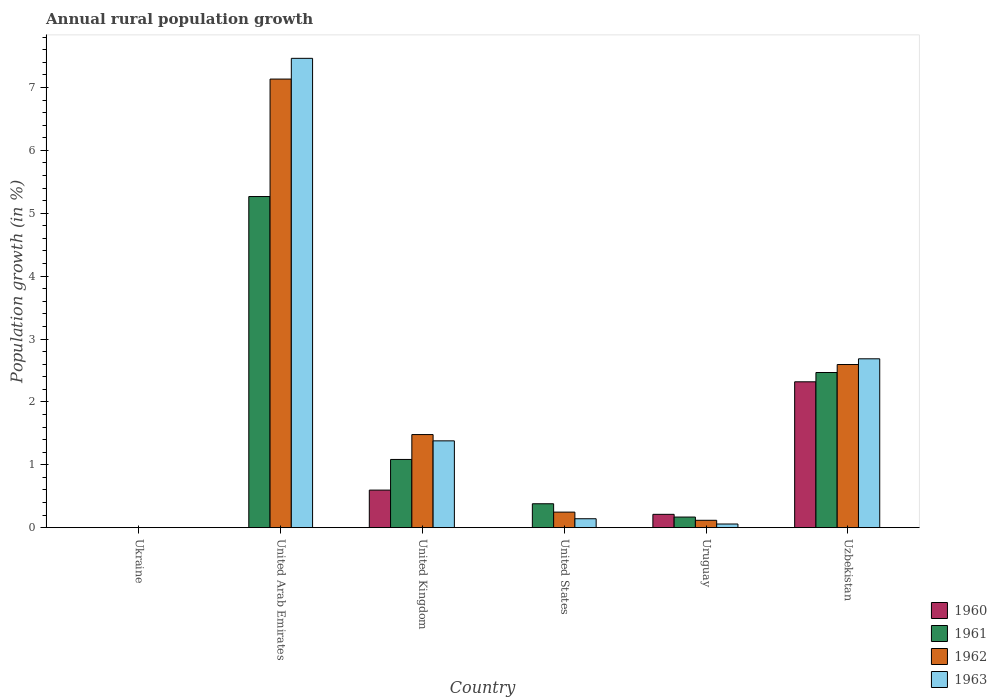How many different coloured bars are there?
Your answer should be very brief. 4. Are the number of bars per tick equal to the number of legend labels?
Provide a succinct answer. No. How many bars are there on the 6th tick from the right?
Provide a short and direct response. 0. What is the label of the 2nd group of bars from the left?
Provide a short and direct response. United Arab Emirates. In how many cases, is the number of bars for a given country not equal to the number of legend labels?
Provide a succinct answer. 3. Across all countries, what is the maximum percentage of rural population growth in 1961?
Make the answer very short. 5.27. In which country was the percentage of rural population growth in 1960 maximum?
Ensure brevity in your answer.  Uzbekistan. What is the total percentage of rural population growth in 1961 in the graph?
Provide a succinct answer. 9.37. What is the difference between the percentage of rural population growth in 1962 in United States and that in Uzbekistan?
Provide a succinct answer. -2.35. What is the difference between the percentage of rural population growth in 1962 in United Kingdom and the percentage of rural population growth in 1961 in United Arab Emirates?
Keep it short and to the point. -3.79. What is the average percentage of rural population growth in 1961 per country?
Provide a succinct answer. 1.56. What is the difference between the percentage of rural population growth of/in 1961 and percentage of rural population growth of/in 1963 in United Arab Emirates?
Make the answer very short. -2.2. What is the ratio of the percentage of rural population growth in 1962 in United Kingdom to that in Uzbekistan?
Provide a succinct answer. 0.57. What is the difference between the highest and the second highest percentage of rural population growth in 1961?
Ensure brevity in your answer.  -1.38. What is the difference between the highest and the lowest percentage of rural population growth in 1960?
Offer a very short reply. 2.32. Is it the case that in every country, the sum of the percentage of rural population growth in 1960 and percentage of rural population growth in 1963 is greater than the sum of percentage of rural population growth in 1961 and percentage of rural population growth in 1962?
Provide a short and direct response. No. How many bars are there?
Offer a terse response. 18. Are all the bars in the graph horizontal?
Provide a succinct answer. No. Does the graph contain any zero values?
Ensure brevity in your answer.  Yes. Does the graph contain grids?
Give a very brief answer. No. Where does the legend appear in the graph?
Provide a succinct answer. Bottom right. How many legend labels are there?
Make the answer very short. 4. How are the legend labels stacked?
Offer a terse response. Vertical. What is the title of the graph?
Ensure brevity in your answer.  Annual rural population growth. Does "1985" appear as one of the legend labels in the graph?
Keep it short and to the point. No. What is the label or title of the Y-axis?
Your answer should be very brief. Population growth (in %). What is the Population growth (in %) of 1960 in Ukraine?
Make the answer very short. 0. What is the Population growth (in %) of 1962 in Ukraine?
Your response must be concise. 0. What is the Population growth (in %) in 1963 in Ukraine?
Your answer should be very brief. 0. What is the Population growth (in %) of 1961 in United Arab Emirates?
Make the answer very short. 5.27. What is the Population growth (in %) of 1962 in United Arab Emirates?
Your answer should be very brief. 7.13. What is the Population growth (in %) in 1963 in United Arab Emirates?
Offer a terse response. 7.46. What is the Population growth (in %) of 1960 in United Kingdom?
Offer a terse response. 0.6. What is the Population growth (in %) in 1961 in United Kingdom?
Ensure brevity in your answer.  1.08. What is the Population growth (in %) of 1962 in United Kingdom?
Give a very brief answer. 1.48. What is the Population growth (in %) in 1963 in United Kingdom?
Your answer should be compact. 1.38. What is the Population growth (in %) in 1960 in United States?
Your answer should be very brief. 0. What is the Population growth (in %) in 1961 in United States?
Give a very brief answer. 0.38. What is the Population growth (in %) in 1962 in United States?
Offer a terse response. 0.25. What is the Population growth (in %) of 1963 in United States?
Offer a very short reply. 0.14. What is the Population growth (in %) of 1960 in Uruguay?
Give a very brief answer. 0.21. What is the Population growth (in %) of 1961 in Uruguay?
Offer a terse response. 0.17. What is the Population growth (in %) of 1962 in Uruguay?
Offer a very short reply. 0.12. What is the Population growth (in %) of 1963 in Uruguay?
Provide a succinct answer. 0.06. What is the Population growth (in %) in 1960 in Uzbekistan?
Your response must be concise. 2.32. What is the Population growth (in %) of 1961 in Uzbekistan?
Give a very brief answer. 2.47. What is the Population growth (in %) of 1962 in Uzbekistan?
Your answer should be compact. 2.59. What is the Population growth (in %) in 1963 in Uzbekistan?
Provide a succinct answer. 2.69. Across all countries, what is the maximum Population growth (in %) of 1960?
Offer a very short reply. 2.32. Across all countries, what is the maximum Population growth (in %) in 1961?
Offer a terse response. 5.27. Across all countries, what is the maximum Population growth (in %) of 1962?
Provide a short and direct response. 7.13. Across all countries, what is the maximum Population growth (in %) in 1963?
Keep it short and to the point. 7.46. Across all countries, what is the minimum Population growth (in %) of 1963?
Provide a short and direct response. 0. What is the total Population growth (in %) of 1960 in the graph?
Give a very brief answer. 3.13. What is the total Population growth (in %) of 1961 in the graph?
Provide a short and direct response. 9.37. What is the total Population growth (in %) of 1962 in the graph?
Provide a short and direct response. 11.57. What is the total Population growth (in %) of 1963 in the graph?
Keep it short and to the point. 11.73. What is the difference between the Population growth (in %) in 1961 in United Arab Emirates and that in United Kingdom?
Offer a very short reply. 4.18. What is the difference between the Population growth (in %) of 1962 in United Arab Emirates and that in United Kingdom?
Provide a succinct answer. 5.65. What is the difference between the Population growth (in %) in 1963 in United Arab Emirates and that in United Kingdom?
Offer a very short reply. 6.08. What is the difference between the Population growth (in %) in 1961 in United Arab Emirates and that in United States?
Provide a short and direct response. 4.89. What is the difference between the Population growth (in %) of 1962 in United Arab Emirates and that in United States?
Offer a very short reply. 6.89. What is the difference between the Population growth (in %) in 1963 in United Arab Emirates and that in United States?
Keep it short and to the point. 7.32. What is the difference between the Population growth (in %) in 1961 in United Arab Emirates and that in Uruguay?
Keep it short and to the point. 5.1. What is the difference between the Population growth (in %) of 1962 in United Arab Emirates and that in Uruguay?
Give a very brief answer. 7.02. What is the difference between the Population growth (in %) of 1963 in United Arab Emirates and that in Uruguay?
Your answer should be very brief. 7.41. What is the difference between the Population growth (in %) in 1961 in United Arab Emirates and that in Uzbekistan?
Your answer should be very brief. 2.8. What is the difference between the Population growth (in %) of 1962 in United Arab Emirates and that in Uzbekistan?
Your answer should be very brief. 4.54. What is the difference between the Population growth (in %) of 1963 in United Arab Emirates and that in Uzbekistan?
Your answer should be compact. 4.78. What is the difference between the Population growth (in %) of 1961 in United Kingdom and that in United States?
Your answer should be very brief. 0.7. What is the difference between the Population growth (in %) of 1962 in United Kingdom and that in United States?
Keep it short and to the point. 1.23. What is the difference between the Population growth (in %) in 1963 in United Kingdom and that in United States?
Offer a terse response. 1.24. What is the difference between the Population growth (in %) in 1960 in United Kingdom and that in Uruguay?
Make the answer very short. 0.39. What is the difference between the Population growth (in %) in 1961 in United Kingdom and that in Uruguay?
Provide a short and direct response. 0.92. What is the difference between the Population growth (in %) of 1962 in United Kingdom and that in Uruguay?
Offer a terse response. 1.36. What is the difference between the Population growth (in %) of 1963 in United Kingdom and that in Uruguay?
Offer a very short reply. 1.32. What is the difference between the Population growth (in %) of 1960 in United Kingdom and that in Uzbekistan?
Make the answer very short. -1.72. What is the difference between the Population growth (in %) of 1961 in United Kingdom and that in Uzbekistan?
Offer a very short reply. -1.38. What is the difference between the Population growth (in %) of 1962 in United Kingdom and that in Uzbekistan?
Your answer should be compact. -1.11. What is the difference between the Population growth (in %) in 1963 in United Kingdom and that in Uzbekistan?
Keep it short and to the point. -1.3. What is the difference between the Population growth (in %) of 1961 in United States and that in Uruguay?
Provide a short and direct response. 0.21. What is the difference between the Population growth (in %) in 1962 in United States and that in Uruguay?
Ensure brevity in your answer.  0.13. What is the difference between the Population growth (in %) in 1963 in United States and that in Uruguay?
Your answer should be compact. 0.08. What is the difference between the Population growth (in %) of 1961 in United States and that in Uzbekistan?
Make the answer very short. -2.09. What is the difference between the Population growth (in %) in 1962 in United States and that in Uzbekistan?
Ensure brevity in your answer.  -2.35. What is the difference between the Population growth (in %) in 1963 in United States and that in Uzbekistan?
Your answer should be very brief. -2.54. What is the difference between the Population growth (in %) in 1960 in Uruguay and that in Uzbekistan?
Make the answer very short. -2.11. What is the difference between the Population growth (in %) of 1961 in Uruguay and that in Uzbekistan?
Ensure brevity in your answer.  -2.3. What is the difference between the Population growth (in %) of 1962 in Uruguay and that in Uzbekistan?
Your response must be concise. -2.48. What is the difference between the Population growth (in %) of 1963 in Uruguay and that in Uzbekistan?
Offer a very short reply. -2.63. What is the difference between the Population growth (in %) in 1961 in United Arab Emirates and the Population growth (in %) in 1962 in United Kingdom?
Your answer should be very brief. 3.79. What is the difference between the Population growth (in %) in 1961 in United Arab Emirates and the Population growth (in %) in 1963 in United Kingdom?
Keep it short and to the point. 3.89. What is the difference between the Population growth (in %) in 1962 in United Arab Emirates and the Population growth (in %) in 1963 in United Kingdom?
Keep it short and to the point. 5.75. What is the difference between the Population growth (in %) of 1961 in United Arab Emirates and the Population growth (in %) of 1962 in United States?
Provide a short and direct response. 5.02. What is the difference between the Population growth (in %) of 1961 in United Arab Emirates and the Population growth (in %) of 1963 in United States?
Offer a terse response. 5.12. What is the difference between the Population growth (in %) of 1962 in United Arab Emirates and the Population growth (in %) of 1963 in United States?
Keep it short and to the point. 6.99. What is the difference between the Population growth (in %) in 1961 in United Arab Emirates and the Population growth (in %) in 1962 in Uruguay?
Offer a very short reply. 5.15. What is the difference between the Population growth (in %) in 1961 in United Arab Emirates and the Population growth (in %) in 1963 in Uruguay?
Ensure brevity in your answer.  5.21. What is the difference between the Population growth (in %) of 1962 in United Arab Emirates and the Population growth (in %) of 1963 in Uruguay?
Offer a terse response. 7.08. What is the difference between the Population growth (in %) of 1961 in United Arab Emirates and the Population growth (in %) of 1962 in Uzbekistan?
Your answer should be compact. 2.67. What is the difference between the Population growth (in %) in 1961 in United Arab Emirates and the Population growth (in %) in 1963 in Uzbekistan?
Provide a short and direct response. 2.58. What is the difference between the Population growth (in %) in 1962 in United Arab Emirates and the Population growth (in %) in 1963 in Uzbekistan?
Ensure brevity in your answer.  4.45. What is the difference between the Population growth (in %) in 1960 in United Kingdom and the Population growth (in %) in 1961 in United States?
Keep it short and to the point. 0.22. What is the difference between the Population growth (in %) in 1960 in United Kingdom and the Population growth (in %) in 1963 in United States?
Provide a succinct answer. 0.46. What is the difference between the Population growth (in %) in 1961 in United Kingdom and the Population growth (in %) in 1962 in United States?
Give a very brief answer. 0.84. What is the difference between the Population growth (in %) in 1961 in United Kingdom and the Population growth (in %) in 1963 in United States?
Your response must be concise. 0.94. What is the difference between the Population growth (in %) in 1962 in United Kingdom and the Population growth (in %) in 1963 in United States?
Your answer should be compact. 1.34. What is the difference between the Population growth (in %) of 1960 in United Kingdom and the Population growth (in %) of 1961 in Uruguay?
Your response must be concise. 0.43. What is the difference between the Population growth (in %) of 1960 in United Kingdom and the Population growth (in %) of 1962 in Uruguay?
Provide a succinct answer. 0.48. What is the difference between the Population growth (in %) in 1960 in United Kingdom and the Population growth (in %) in 1963 in Uruguay?
Offer a very short reply. 0.54. What is the difference between the Population growth (in %) of 1961 in United Kingdom and the Population growth (in %) of 1962 in Uruguay?
Provide a succinct answer. 0.97. What is the difference between the Population growth (in %) of 1961 in United Kingdom and the Population growth (in %) of 1963 in Uruguay?
Your response must be concise. 1.03. What is the difference between the Population growth (in %) of 1962 in United Kingdom and the Population growth (in %) of 1963 in Uruguay?
Give a very brief answer. 1.42. What is the difference between the Population growth (in %) in 1960 in United Kingdom and the Population growth (in %) in 1961 in Uzbekistan?
Your answer should be very brief. -1.87. What is the difference between the Population growth (in %) of 1960 in United Kingdom and the Population growth (in %) of 1962 in Uzbekistan?
Ensure brevity in your answer.  -2. What is the difference between the Population growth (in %) in 1960 in United Kingdom and the Population growth (in %) in 1963 in Uzbekistan?
Your response must be concise. -2.09. What is the difference between the Population growth (in %) of 1961 in United Kingdom and the Population growth (in %) of 1962 in Uzbekistan?
Provide a short and direct response. -1.51. What is the difference between the Population growth (in %) in 1961 in United Kingdom and the Population growth (in %) in 1963 in Uzbekistan?
Offer a very short reply. -1.6. What is the difference between the Population growth (in %) in 1962 in United Kingdom and the Population growth (in %) in 1963 in Uzbekistan?
Ensure brevity in your answer.  -1.21. What is the difference between the Population growth (in %) in 1961 in United States and the Population growth (in %) in 1962 in Uruguay?
Ensure brevity in your answer.  0.26. What is the difference between the Population growth (in %) in 1961 in United States and the Population growth (in %) in 1963 in Uruguay?
Your answer should be very brief. 0.32. What is the difference between the Population growth (in %) in 1962 in United States and the Population growth (in %) in 1963 in Uruguay?
Provide a succinct answer. 0.19. What is the difference between the Population growth (in %) in 1961 in United States and the Population growth (in %) in 1962 in Uzbekistan?
Your answer should be very brief. -2.21. What is the difference between the Population growth (in %) of 1961 in United States and the Population growth (in %) of 1963 in Uzbekistan?
Provide a short and direct response. -2.31. What is the difference between the Population growth (in %) of 1962 in United States and the Population growth (in %) of 1963 in Uzbekistan?
Your answer should be very brief. -2.44. What is the difference between the Population growth (in %) of 1960 in Uruguay and the Population growth (in %) of 1961 in Uzbekistan?
Ensure brevity in your answer.  -2.26. What is the difference between the Population growth (in %) of 1960 in Uruguay and the Population growth (in %) of 1962 in Uzbekistan?
Keep it short and to the point. -2.38. What is the difference between the Population growth (in %) in 1960 in Uruguay and the Population growth (in %) in 1963 in Uzbekistan?
Provide a succinct answer. -2.47. What is the difference between the Population growth (in %) of 1961 in Uruguay and the Population growth (in %) of 1962 in Uzbekistan?
Provide a short and direct response. -2.43. What is the difference between the Population growth (in %) of 1961 in Uruguay and the Population growth (in %) of 1963 in Uzbekistan?
Ensure brevity in your answer.  -2.52. What is the difference between the Population growth (in %) of 1962 in Uruguay and the Population growth (in %) of 1963 in Uzbekistan?
Offer a terse response. -2.57. What is the average Population growth (in %) of 1960 per country?
Keep it short and to the point. 0.52. What is the average Population growth (in %) in 1961 per country?
Ensure brevity in your answer.  1.56. What is the average Population growth (in %) in 1962 per country?
Your answer should be compact. 1.93. What is the average Population growth (in %) of 1963 per country?
Make the answer very short. 1.95. What is the difference between the Population growth (in %) in 1961 and Population growth (in %) in 1962 in United Arab Emirates?
Your answer should be very brief. -1.87. What is the difference between the Population growth (in %) of 1961 and Population growth (in %) of 1963 in United Arab Emirates?
Offer a very short reply. -2.2. What is the difference between the Population growth (in %) in 1962 and Population growth (in %) in 1963 in United Arab Emirates?
Provide a short and direct response. -0.33. What is the difference between the Population growth (in %) in 1960 and Population growth (in %) in 1961 in United Kingdom?
Ensure brevity in your answer.  -0.49. What is the difference between the Population growth (in %) in 1960 and Population growth (in %) in 1962 in United Kingdom?
Offer a terse response. -0.88. What is the difference between the Population growth (in %) of 1960 and Population growth (in %) of 1963 in United Kingdom?
Offer a terse response. -0.78. What is the difference between the Population growth (in %) in 1961 and Population growth (in %) in 1962 in United Kingdom?
Offer a terse response. -0.4. What is the difference between the Population growth (in %) of 1961 and Population growth (in %) of 1963 in United Kingdom?
Give a very brief answer. -0.3. What is the difference between the Population growth (in %) of 1962 and Population growth (in %) of 1963 in United Kingdom?
Provide a succinct answer. 0.1. What is the difference between the Population growth (in %) of 1961 and Population growth (in %) of 1962 in United States?
Provide a short and direct response. 0.13. What is the difference between the Population growth (in %) in 1961 and Population growth (in %) in 1963 in United States?
Provide a succinct answer. 0.24. What is the difference between the Population growth (in %) of 1962 and Population growth (in %) of 1963 in United States?
Your response must be concise. 0.11. What is the difference between the Population growth (in %) of 1960 and Population growth (in %) of 1961 in Uruguay?
Offer a terse response. 0.04. What is the difference between the Population growth (in %) in 1960 and Population growth (in %) in 1962 in Uruguay?
Offer a very short reply. 0.09. What is the difference between the Population growth (in %) of 1960 and Population growth (in %) of 1963 in Uruguay?
Provide a succinct answer. 0.15. What is the difference between the Population growth (in %) in 1961 and Population growth (in %) in 1962 in Uruguay?
Offer a terse response. 0.05. What is the difference between the Population growth (in %) in 1961 and Population growth (in %) in 1963 in Uruguay?
Offer a very short reply. 0.11. What is the difference between the Population growth (in %) in 1962 and Population growth (in %) in 1963 in Uruguay?
Provide a short and direct response. 0.06. What is the difference between the Population growth (in %) in 1960 and Population growth (in %) in 1961 in Uzbekistan?
Your answer should be compact. -0.15. What is the difference between the Population growth (in %) in 1960 and Population growth (in %) in 1962 in Uzbekistan?
Make the answer very short. -0.27. What is the difference between the Population growth (in %) of 1960 and Population growth (in %) of 1963 in Uzbekistan?
Give a very brief answer. -0.37. What is the difference between the Population growth (in %) in 1961 and Population growth (in %) in 1962 in Uzbekistan?
Provide a succinct answer. -0.13. What is the difference between the Population growth (in %) in 1961 and Population growth (in %) in 1963 in Uzbekistan?
Ensure brevity in your answer.  -0.22. What is the difference between the Population growth (in %) in 1962 and Population growth (in %) in 1963 in Uzbekistan?
Offer a very short reply. -0.09. What is the ratio of the Population growth (in %) in 1961 in United Arab Emirates to that in United Kingdom?
Ensure brevity in your answer.  4.85. What is the ratio of the Population growth (in %) of 1962 in United Arab Emirates to that in United Kingdom?
Provide a short and direct response. 4.82. What is the ratio of the Population growth (in %) of 1963 in United Arab Emirates to that in United Kingdom?
Make the answer very short. 5.41. What is the ratio of the Population growth (in %) in 1961 in United Arab Emirates to that in United States?
Offer a very short reply. 13.87. What is the ratio of the Population growth (in %) in 1962 in United Arab Emirates to that in United States?
Provide a succinct answer. 28.89. What is the ratio of the Population growth (in %) of 1963 in United Arab Emirates to that in United States?
Provide a short and direct response. 52.72. What is the ratio of the Population growth (in %) of 1961 in United Arab Emirates to that in Uruguay?
Keep it short and to the point. 31.29. What is the ratio of the Population growth (in %) in 1962 in United Arab Emirates to that in Uruguay?
Your answer should be compact. 61. What is the ratio of the Population growth (in %) of 1963 in United Arab Emirates to that in Uruguay?
Offer a very short reply. 129.07. What is the ratio of the Population growth (in %) of 1961 in United Arab Emirates to that in Uzbekistan?
Offer a very short reply. 2.13. What is the ratio of the Population growth (in %) in 1962 in United Arab Emirates to that in Uzbekistan?
Ensure brevity in your answer.  2.75. What is the ratio of the Population growth (in %) in 1963 in United Arab Emirates to that in Uzbekistan?
Ensure brevity in your answer.  2.78. What is the ratio of the Population growth (in %) in 1961 in United Kingdom to that in United States?
Your response must be concise. 2.86. What is the ratio of the Population growth (in %) of 1962 in United Kingdom to that in United States?
Provide a short and direct response. 5.99. What is the ratio of the Population growth (in %) of 1963 in United Kingdom to that in United States?
Your answer should be compact. 9.75. What is the ratio of the Population growth (in %) of 1960 in United Kingdom to that in Uruguay?
Ensure brevity in your answer.  2.82. What is the ratio of the Population growth (in %) of 1961 in United Kingdom to that in Uruguay?
Your answer should be compact. 6.44. What is the ratio of the Population growth (in %) of 1962 in United Kingdom to that in Uruguay?
Offer a very short reply. 12.66. What is the ratio of the Population growth (in %) of 1963 in United Kingdom to that in Uruguay?
Make the answer very short. 23.87. What is the ratio of the Population growth (in %) in 1960 in United Kingdom to that in Uzbekistan?
Provide a short and direct response. 0.26. What is the ratio of the Population growth (in %) in 1961 in United Kingdom to that in Uzbekistan?
Offer a very short reply. 0.44. What is the ratio of the Population growth (in %) of 1962 in United Kingdom to that in Uzbekistan?
Your answer should be compact. 0.57. What is the ratio of the Population growth (in %) of 1963 in United Kingdom to that in Uzbekistan?
Provide a short and direct response. 0.51. What is the ratio of the Population growth (in %) in 1961 in United States to that in Uruguay?
Offer a very short reply. 2.26. What is the ratio of the Population growth (in %) of 1962 in United States to that in Uruguay?
Your response must be concise. 2.11. What is the ratio of the Population growth (in %) of 1963 in United States to that in Uruguay?
Offer a terse response. 2.45. What is the ratio of the Population growth (in %) in 1961 in United States to that in Uzbekistan?
Make the answer very short. 0.15. What is the ratio of the Population growth (in %) in 1962 in United States to that in Uzbekistan?
Your answer should be very brief. 0.1. What is the ratio of the Population growth (in %) in 1963 in United States to that in Uzbekistan?
Make the answer very short. 0.05. What is the ratio of the Population growth (in %) of 1960 in Uruguay to that in Uzbekistan?
Make the answer very short. 0.09. What is the ratio of the Population growth (in %) in 1961 in Uruguay to that in Uzbekistan?
Make the answer very short. 0.07. What is the ratio of the Population growth (in %) in 1962 in Uruguay to that in Uzbekistan?
Your response must be concise. 0.05. What is the ratio of the Population growth (in %) in 1963 in Uruguay to that in Uzbekistan?
Provide a short and direct response. 0.02. What is the difference between the highest and the second highest Population growth (in %) of 1960?
Make the answer very short. 1.72. What is the difference between the highest and the second highest Population growth (in %) in 1961?
Provide a succinct answer. 2.8. What is the difference between the highest and the second highest Population growth (in %) of 1962?
Keep it short and to the point. 4.54. What is the difference between the highest and the second highest Population growth (in %) in 1963?
Your answer should be very brief. 4.78. What is the difference between the highest and the lowest Population growth (in %) of 1960?
Make the answer very short. 2.32. What is the difference between the highest and the lowest Population growth (in %) of 1961?
Keep it short and to the point. 5.27. What is the difference between the highest and the lowest Population growth (in %) of 1962?
Give a very brief answer. 7.13. What is the difference between the highest and the lowest Population growth (in %) of 1963?
Provide a succinct answer. 7.46. 